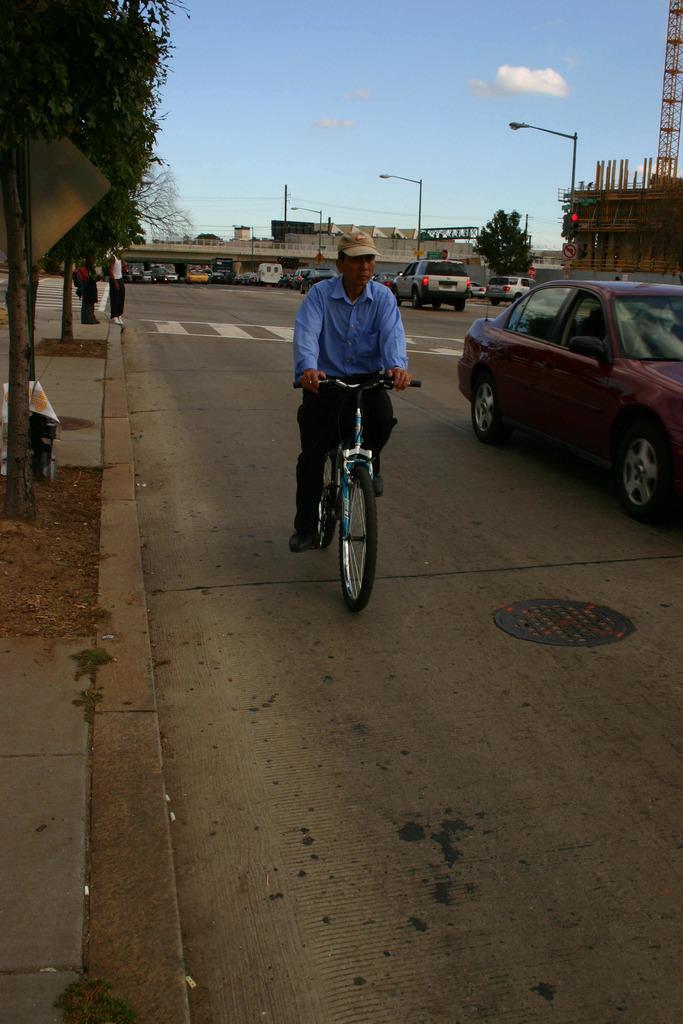Please provide a concise description of this image. In the image we can see there is man who is sitting on the bicycle which is on the road and there are vehicles which are parked on the road and there are lot of trees and people are standing on the footpath. 